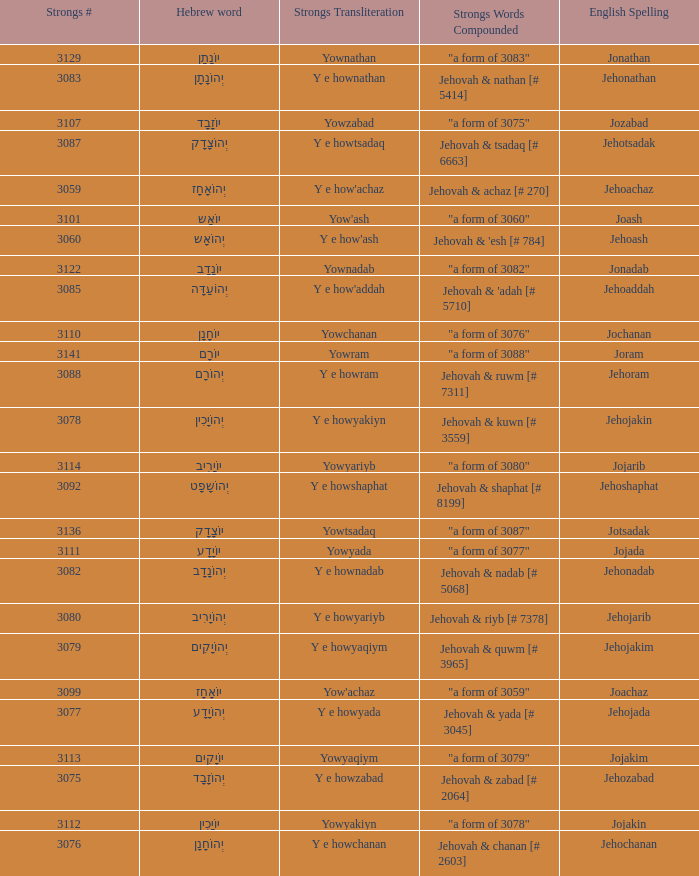What is the strongs # of the english spelling word jehojakin? 3078.0. 